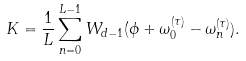<formula> <loc_0><loc_0><loc_500><loc_500>K = \frac { 1 } { L } \sum ^ { L - 1 } _ { n = 0 } W _ { d - 1 } ( \phi + \omega _ { 0 } ^ { ( \tau ) } - \omega _ { n } ^ { ( \tau ) } ) .</formula> 